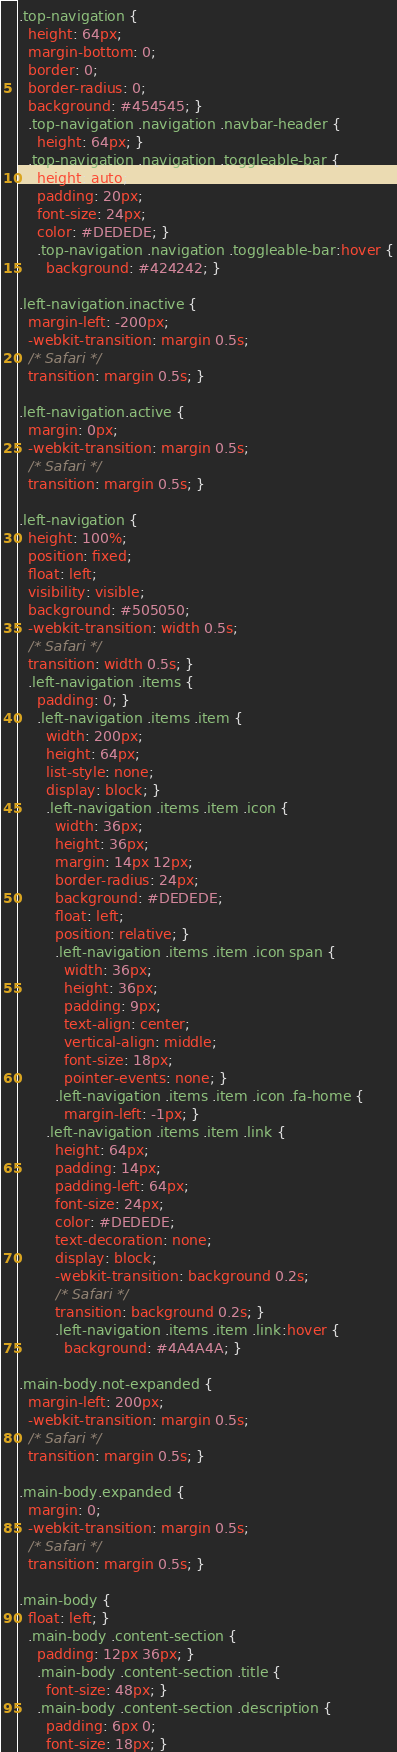<code> <loc_0><loc_0><loc_500><loc_500><_CSS_>.top-navigation {
  height: 64px;
  margin-bottom: 0;
  border: 0;
  border-radius: 0;
  background: #454545; }
  .top-navigation .navigation .navbar-header {
    height: 64px; }
  .top-navigation .navigation .toggleable-bar {
    height: auto;
    padding: 20px;
    font-size: 24px;
    color: #DEDEDE; }
    .top-navigation .navigation .toggleable-bar:hover {
      background: #424242; }

.left-navigation.inactive {
  margin-left: -200px;
  -webkit-transition: margin 0.5s;
  /* Safari */
  transition: margin 0.5s; }

.left-navigation.active {
  margin: 0px;
  -webkit-transition: margin 0.5s;
  /* Safari */
  transition: margin 0.5s; }

.left-navigation {
  height: 100%;
  position: fixed;
  float: left;
  visibility: visible;
  background: #505050;
  -webkit-transition: width 0.5s;
  /* Safari */
  transition: width 0.5s; }
  .left-navigation .items {
    padding: 0; }
    .left-navigation .items .item {
      width: 200px;
      height: 64px;
      list-style: none;
      display: block; }
      .left-navigation .items .item .icon {
        width: 36px;
        height: 36px;
        margin: 14px 12px;
        border-radius: 24px;
        background: #DEDEDE;
        float: left;
        position: relative; }
        .left-navigation .items .item .icon span {
          width: 36px;
          height: 36px;
          padding: 9px;
          text-align: center;
          vertical-align: middle;
          font-size: 18px;
          pointer-events: none; }
        .left-navigation .items .item .icon .fa-home {
          margin-left: -1px; }
      .left-navigation .items .item .link {
        height: 64px;
        padding: 14px;
        padding-left: 64px;
        font-size: 24px;
        color: #DEDEDE;
        text-decoration: none;
        display: block;
        -webkit-transition: background 0.2s;
        /* Safari */
        transition: background 0.2s; }
        .left-navigation .items .item .link:hover {
          background: #4A4A4A; }

.main-body.not-expanded {
  margin-left: 200px;
  -webkit-transition: margin 0.5s;
  /* Safari */
  transition: margin 0.5s; }

.main-body.expanded {
  margin: 0;
  -webkit-transition: margin 0.5s;
  /* Safari */
  transition: margin 0.5s; }

.main-body {
  float: left; }
  .main-body .content-section {
    padding: 12px 36px; }
    .main-body .content-section .title {
      font-size: 48px; }
    .main-body .content-section .description {
      padding: 6px 0;
      font-size: 18px; }</code> 